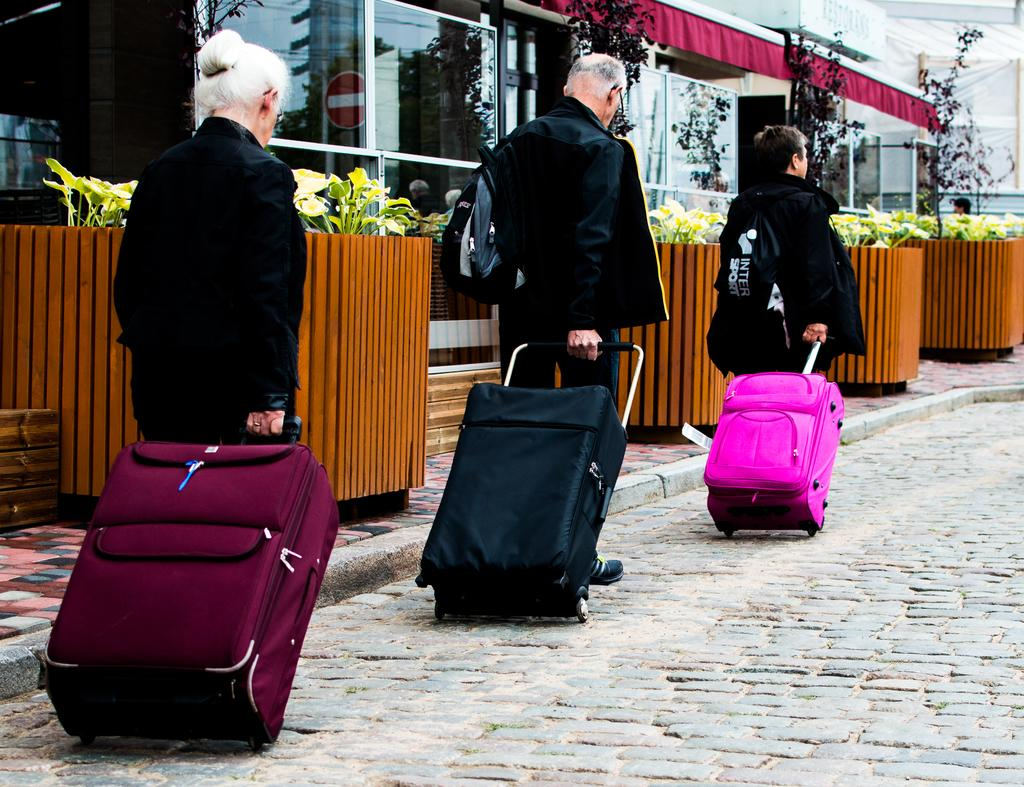What is located in the middle of the image? There are plants in the middle of the image. How many people are in the image? There are three persons in the image. What are the people wearing? The persons are wearing black dress. What are the people holding in the image? The persons are holding trolley bags. What can be seen in the background of the image? There is a building in the background of the image. What type of pollution can be seen in the image? There is no pollution visible in the image. Can you tell me how many crayons are being used by the persons in the image? There are no crayons present in the image. 